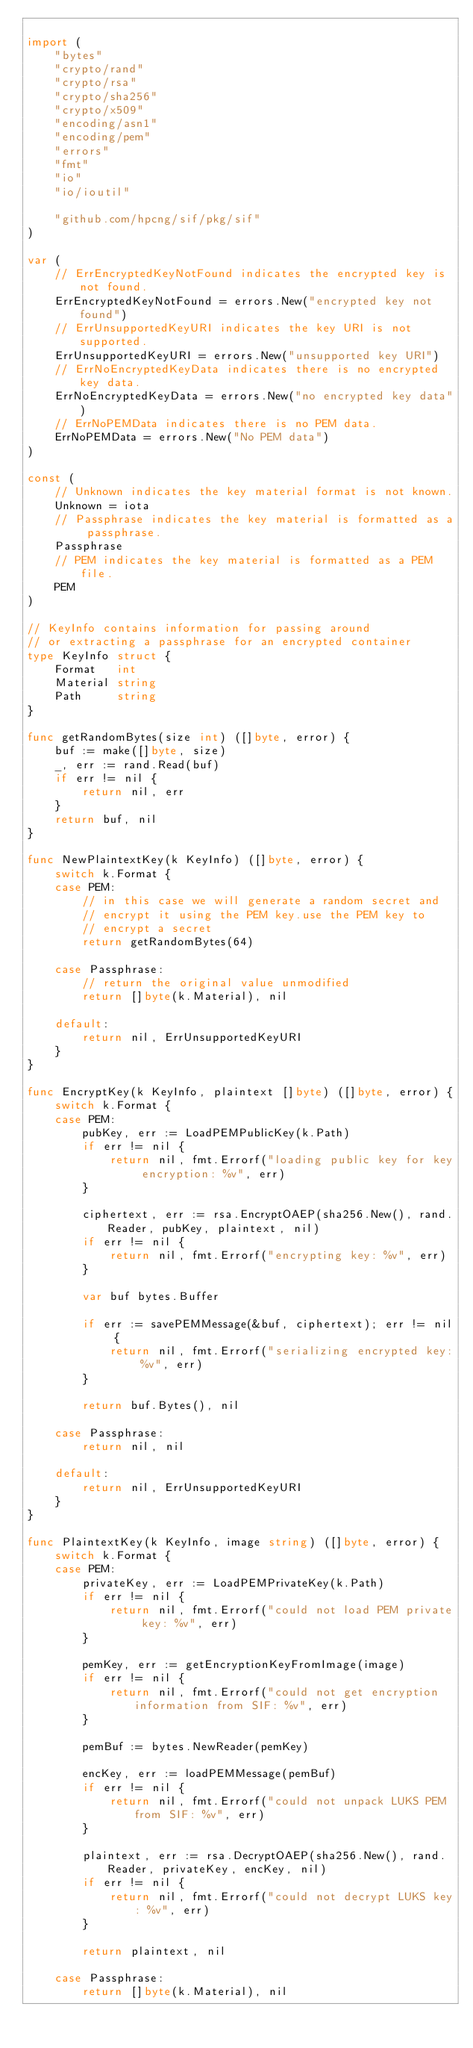<code> <loc_0><loc_0><loc_500><loc_500><_Go_>
import (
	"bytes"
	"crypto/rand"
	"crypto/rsa"
	"crypto/sha256"
	"crypto/x509"
	"encoding/asn1"
	"encoding/pem"
	"errors"
	"fmt"
	"io"
	"io/ioutil"

	"github.com/hpcng/sif/pkg/sif"
)

var (
	// ErrEncryptedKeyNotFound indicates the encrypted key is not found.
	ErrEncryptedKeyNotFound = errors.New("encrypted key not found")
	// ErrUnsupportedKeyURI indicates the key URI is not supported.
	ErrUnsupportedKeyURI = errors.New("unsupported key URI")
	// ErrNoEncryptedKeyData indicates there is no encrypted key data.
	ErrNoEncryptedKeyData = errors.New("no encrypted key data")
	// ErrNoPEMData indicates there is no PEM data.
	ErrNoPEMData = errors.New("No PEM data")
)

const (
	// Unknown indicates the key material format is not known.
	Unknown = iota
	// Passphrase indicates the key material is formatted as a passphrase.
	Passphrase
	// PEM indicates the key material is formatted as a PEM file.
	PEM
)

// KeyInfo contains information for passing around
// or extracting a passphrase for an encrypted container
type KeyInfo struct {
	Format   int
	Material string
	Path     string
}

func getRandomBytes(size int) ([]byte, error) {
	buf := make([]byte, size)
	_, err := rand.Read(buf)
	if err != nil {
		return nil, err
	}
	return buf, nil
}

func NewPlaintextKey(k KeyInfo) ([]byte, error) {
	switch k.Format {
	case PEM:
		// in this case we will generate a random secret and
		// encrypt it using the PEM key.use the PEM key to
		// encrypt a secret
		return getRandomBytes(64)

	case Passphrase:
		// return the original value unmodified
		return []byte(k.Material), nil

	default:
		return nil, ErrUnsupportedKeyURI
	}
}

func EncryptKey(k KeyInfo, plaintext []byte) ([]byte, error) {
	switch k.Format {
	case PEM:
		pubKey, err := LoadPEMPublicKey(k.Path)
		if err != nil {
			return nil, fmt.Errorf("loading public key for key encryption: %v", err)
		}

		ciphertext, err := rsa.EncryptOAEP(sha256.New(), rand.Reader, pubKey, plaintext, nil)
		if err != nil {
			return nil, fmt.Errorf("encrypting key: %v", err)
		}

		var buf bytes.Buffer

		if err := savePEMMessage(&buf, ciphertext); err != nil {
			return nil, fmt.Errorf("serializing encrypted key: %v", err)
		}

		return buf.Bytes(), nil

	case Passphrase:
		return nil, nil

	default:
		return nil, ErrUnsupportedKeyURI
	}
}

func PlaintextKey(k KeyInfo, image string) ([]byte, error) {
	switch k.Format {
	case PEM:
		privateKey, err := LoadPEMPrivateKey(k.Path)
		if err != nil {
			return nil, fmt.Errorf("could not load PEM private key: %v", err)
		}

		pemKey, err := getEncryptionKeyFromImage(image)
		if err != nil {
			return nil, fmt.Errorf("could not get encryption information from SIF: %v", err)
		}

		pemBuf := bytes.NewReader(pemKey)

		encKey, err := loadPEMMessage(pemBuf)
		if err != nil {
			return nil, fmt.Errorf("could not unpack LUKS PEM from SIF: %v", err)
		}

		plaintext, err := rsa.DecryptOAEP(sha256.New(), rand.Reader, privateKey, encKey, nil)
		if err != nil {
			return nil, fmt.Errorf("could not decrypt LUKS key: %v", err)
		}

		return plaintext, nil

	case Passphrase:
		return []byte(k.Material), nil
</code> 